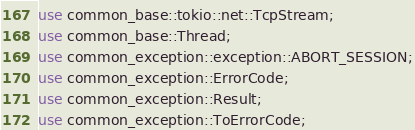<code> <loc_0><loc_0><loc_500><loc_500><_Rust_>
use common_base::tokio::net::TcpStream;
use common_base::Thread;
use common_exception::exception::ABORT_SESSION;
use common_exception::ErrorCode;
use common_exception::Result;
use common_exception::ToErrorCode;</code> 